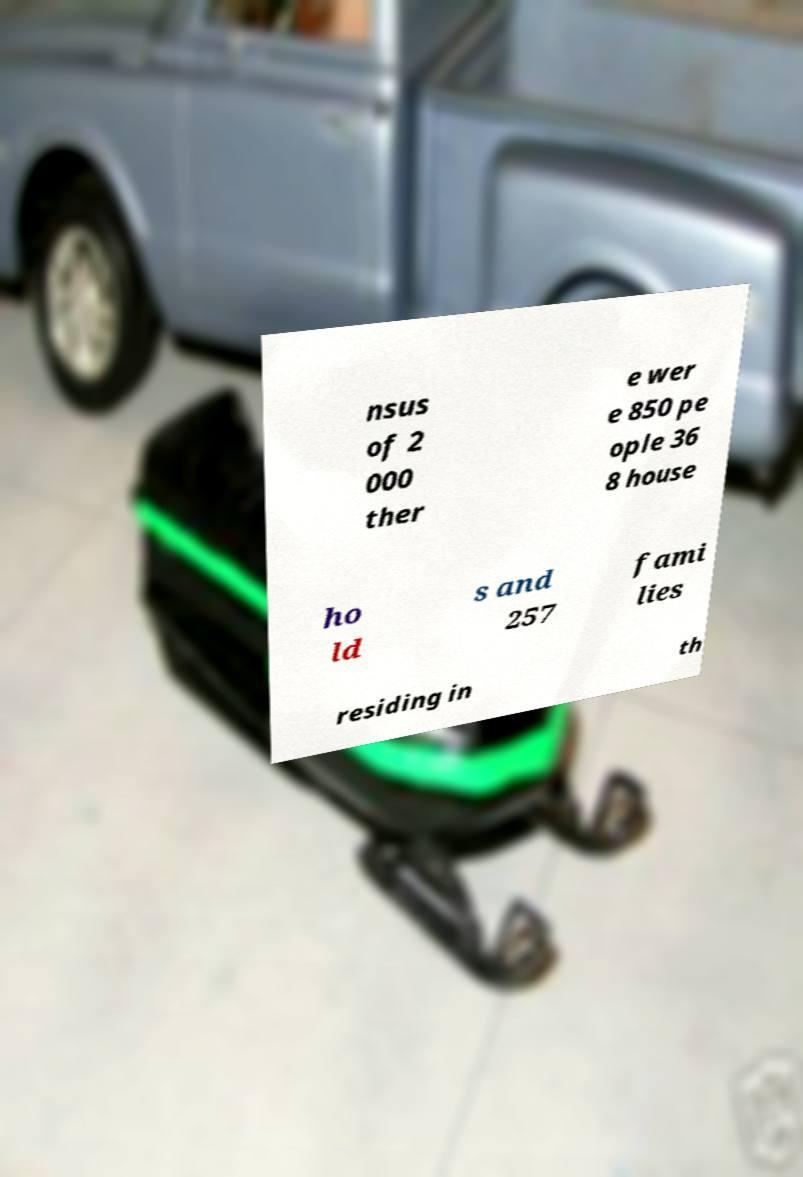For documentation purposes, I need the text within this image transcribed. Could you provide that? nsus of 2 000 ther e wer e 850 pe ople 36 8 house ho ld s and 257 fami lies residing in th 